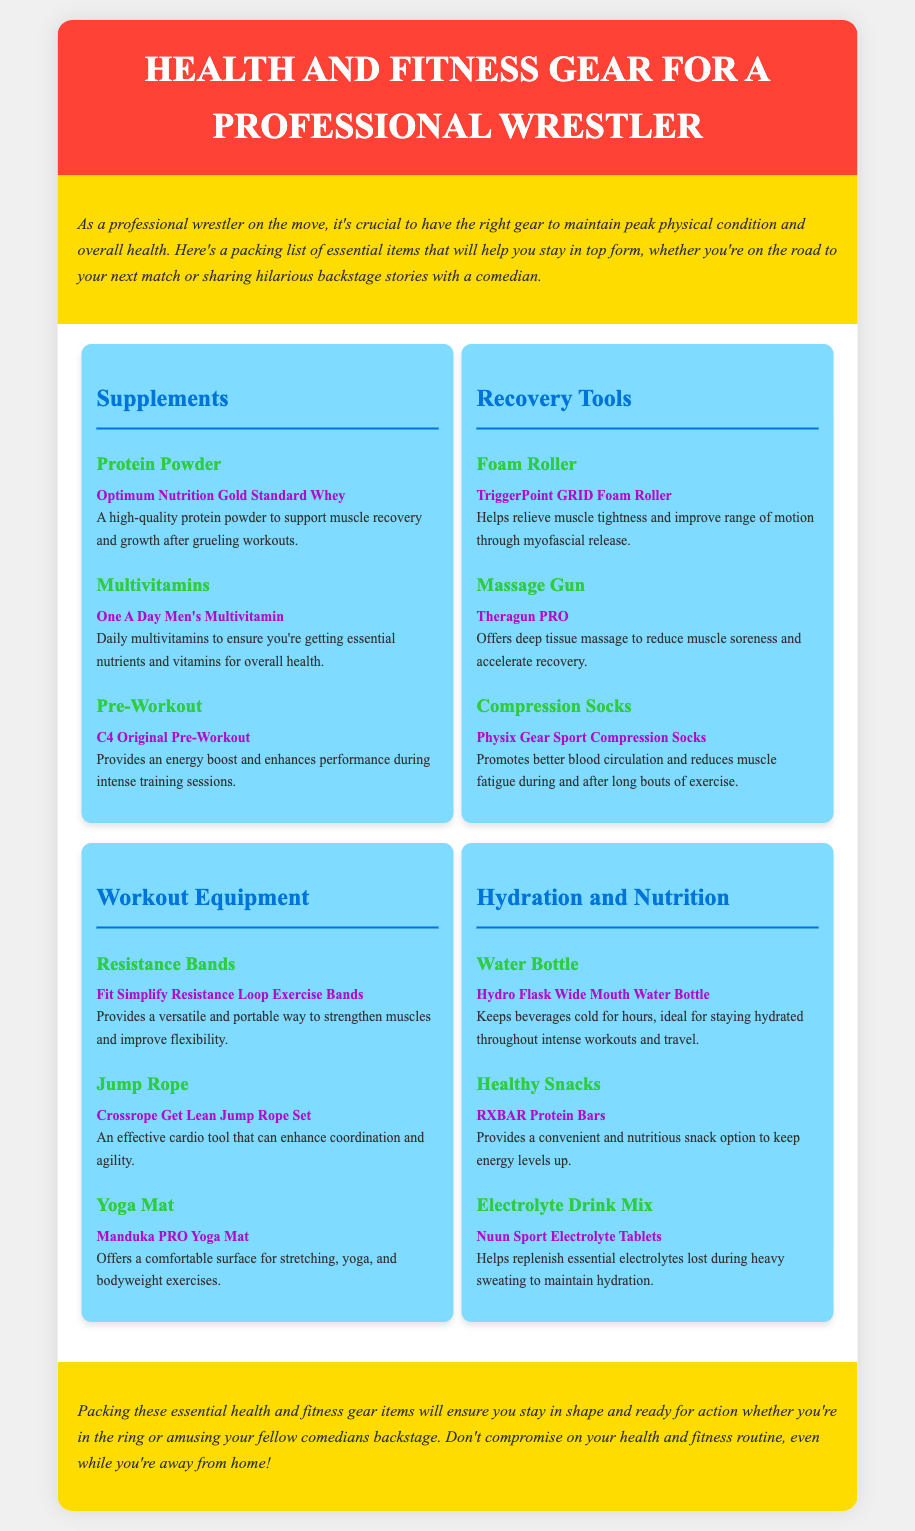What is the brand of the protein powder? The document lists "Optimum Nutrition Gold Standard Whey" as the protein powder brand.
Answer: Optimum Nutrition Gold Standard Whey What item helps alleviate muscle tightness? The foam roller is specifically mentioned as a tool for relieving muscle tightness.
Answer: Foam Roller How many categories of gear are listed in the document? There are four categories mentioned: Supplements, Recovery Tools, Workout Equipment, and Hydration and Nutrition.
Answer: Four What is the brand of the healthy snacks mentioned? The document features "RXBAR Protein Bars" as the healthy snack brand.
Answer: RXBAR Protein Bars What tool is mentioned as providing an energy boost before workouts? "C4 Original Pre-Workout" is explicitly named as the tool for an energy boost.
Answer: C4 Original Pre-Workout What is the purpose of the compression socks? The document states that compression socks promote better blood circulation and reduce muscle fatigue.
Answer: Better blood circulation Which item is used for hydration during workouts? The "Hydro Flask Wide Mouth Water Bottle" is noted for keeping beverages cold and aiding hydration.
Answer: Hydro Flask Wide Mouth Water Bottle What is the brand of the yoga mat? The yoga mat is listed under the brand "Manduka PRO."
Answer: Manduka PRO Which item is used for deep tissue massage? The "Theragun PRO" is specifically mentioned for deep tissue massage purposes.
Answer: Theragun PRO 